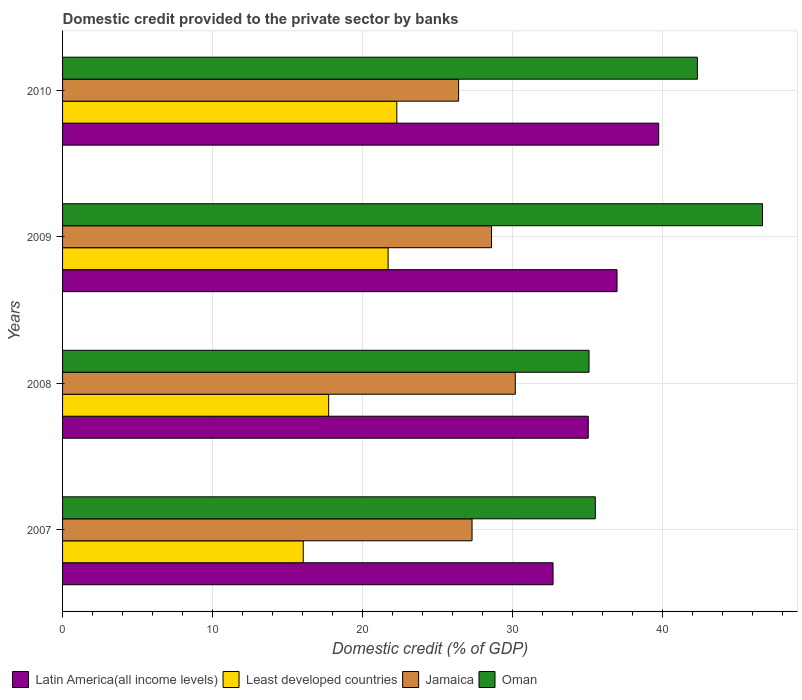How many groups of bars are there?
Your answer should be very brief. 4. In how many cases, is the number of bars for a given year not equal to the number of legend labels?
Make the answer very short. 0. What is the domestic credit provided to the private sector by banks in Latin America(all income levels) in 2010?
Your answer should be very brief. 39.76. Across all years, what is the maximum domestic credit provided to the private sector by banks in Least developed countries?
Ensure brevity in your answer.  22.29. Across all years, what is the minimum domestic credit provided to the private sector by banks in Latin America(all income levels)?
Your answer should be compact. 32.71. In which year was the domestic credit provided to the private sector by banks in Jamaica maximum?
Your answer should be compact. 2008. What is the total domestic credit provided to the private sector by banks in Latin America(all income levels) in the graph?
Your answer should be compact. 144.5. What is the difference between the domestic credit provided to the private sector by banks in Latin America(all income levels) in 2008 and that in 2010?
Your response must be concise. -4.7. What is the difference between the domestic credit provided to the private sector by banks in Jamaica in 2010 and the domestic credit provided to the private sector by banks in Least developed countries in 2009?
Give a very brief answer. 4.7. What is the average domestic credit provided to the private sector by banks in Latin America(all income levels) per year?
Offer a terse response. 36.12. In the year 2008, what is the difference between the domestic credit provided to the private sector by banks in Jamaica and domestic credit provided to the private sector by banks in Latin America(all income levels)?
Keep it short and to the point. -4.87. What is the ratio of the domestic credit provided to the private sector by banks in Least developed countries in 2009 to that in 2010?
Your answer should be compact. 0.97. What is the difference between the highest and the second highest domestic credit provided to the private sector by banks in Jamaica?
Your answer should be compact. 1.58. What is the difference between the highest and the lowest domestic credit provided to the private sector by banks in Oman?
Your answer should be very brief. 11.57. In how many years, is the domestic credit provided to the private sector by banks in Least developed countries greater than the average domestic credit provided to the private sector by banks in Least developed countries taken over all years?
Offer a very short reply. 2. What does the 2nd bar from the top in 2010 represents?
Keep it short and to the point. Jamaica. What does the 4th bar from the bottom in 2009 represents?
Offer a very short reply. Oman. Is it the case that in every year, the sum of the domestic credit provided to the private sector by banks in Oman and domestic credit provided to the private sector by banks in Latin America(all income levels) is greater than the domestic credit provided to the private sector by banks in Jamaica?
Give a very brief answer. Yes. Are all the bars in the graph horizontal?
Provide a succinct answer. Yes. Are the values on the major ticks of X-axis written in scientific E-notation?
Provide a succinct answer. No. Does the graph contain any zero values?
Offer a very short reply. No. Does the graph contain grids?
Your answer should be very brief. Yes. Where does the legend appear in the graph?
Your answer should be very brief. Bottom left. What is the title of the graph?
Provide a short and direct response. Domestic credit provided to the private sector by banks. What is the label or title of the X-axis?
Your answer should be compact. Domestic credit (% of GDP). What is the Domestic credit (% of GDP) in Latin America(all income levels) in 2007?
Provide a short and direct response. 32.71. What is the Domestic credit (% of GDP) of Least developed countries in 2007?
Give a very brief answer. 16.05. What is the Domestic credit (% of GDP) in Jamaica in 2007?
Offer a terse response. 27.31. What is the Domestic credit (% of GDP) in Oman in 2007?
Your response must be concise. 35.53. What is the Domestic credit (% of GDP) in Latin America(all income levels) in 2008?
Ensure brevity in your answer.  35.06. What is the Domestic credit (% of GDP) of Least developed countries in 2008?
Keep it short and to the point. 17.75. What is the Domestic credit (% of GDP) of Jamaica in 2008?
Give a very brief answer. 30.19. What is the Domestic credit (% of GDP) in Oman in 2008?
Provide a short and direct response. 35.11. What is the Domestic credit (% of GDP) of Latin America(all income levels) in 2009?
Provide a succinct answer. 36.98. What is the Domestic credit (% of GDP) in Least developed countries in 2009?
Keep it short and to the point. 21.71. What is the Domestic credit (% of GDP) of Jamaica in 2009?
Offer a terse response. 28.61. What is the Domestic credit (% of GDP) of Oman in 2009?
Keep it short and to the point. 46.68. What is the Domestic credit (% of GDP) of Latin America(all income levels) in 2010?
Make the answer very short. 39.76. What is the Domestic credit (% of GDP) of Least developed countries in 2010?
Offer a terse response. 22.29. What is the Domestic credit (% of GDP) of Jamaica in 2010?
Ensure brevity in your answer.  26.41. What is the Domestic credit (% of GDP) of Oman in 2010?
Offer a very short reply. 42.33. Across all years, what is the maximum Domestic credit (% of GDP) of Latin America(all income levels)?
Your response must be concise. 39.76. Across all years, what is the maximum Domestic credit (% of GDP) in Least developed countries?
Offer a very short reply. 22.29. Across all years, what is the maximum Domestic credit (% of GDP) in Jamaica?
Ensure brevity in your answer.  30.19. Across all years, what is the maximum Domestic credit (% of GDP) in Oman?
Offer a very short reply. 46.68. Across all years, what is the minimum Domestic credit (% of GDP) of Latin America(all income levels)?
Ensure brevity in your answer.  32.71. Across all years, what is the minimum Domestic credit (% of GDP) in Least developed countries?
Make the answer very short. 16.05. Across all years, what is the minimum Domestic credit (% of GDP) in Jamaica?
Offer a terse response. 26.41. Across all years, what is the minimum Domestic credit (% of GDP) of Oman?
Offer a terse response. 35.11. What is the total Domestic credit (% of GDP) of Latin America(all income levels) in the graph?
Make the answer very short. 144.5. What is the total Domestic credit (% of GDP) in Least developed countries in the graph?
Give a very brief answer. 77.8. What is the total Domestic credit (% of GDP) of Jamaica in the graph?
Provide a succinct answer. 112.52. What is the total Domestic credit (% of GDP) of Oman in the graph?
Make the answer very short. 159.65. What is the difference between the Domestic credit (% of GDP) of Latin America(all income levels) in 2007 and that in 2008?
Your response must be concise. -2.35. What is the difference between the Domestic credit (% of GDP) in Least developed countries in 2007 and that in 2008?
Make the answer very short. -1.7. What is the difference between the Domestic credit (% of GDP) of Jamaica in 2007 and that in 2008?
Provide a short and direct response. -2.88. What is the difference between the Domestic credit (% of GDP) of Oman in 2007 and that in 2008?
Provide a short and direct response. 0.42. What is the difference between the Domestic credit (% of GDP) in Latin America(all income levels) in 2007 and that in 2009?
Make the answer very short. -4.27. What is the difference between the Domestic credit (% of GDP) of Least developed countries in 2007 and that in 2009?
Ensure brevity in your answer.  -5.66. What is the difference between the Domestic credit (% of GDP) in Jamaica in 2007 and that in 2009?
Provide a succinct answer. -1.3. What is the difference between the Domestic credit (% of GDP) of Oman in 2007 and that in 2009?
Ensure brevity in your answer.  -11.15. What is the difference between the Domestic credit (% of GDP) in Latin America(all income levels) in 2007 and that in 2010?
Provide a short and direct response. -7.05. What is the difference between the Domestic credit (% of GDP) in Least developed countries in 2007 and that in 2010?
Keep it short and to the point. -6.24. What is the difference between the Domestic credit (% of GDP) in Jamaica in 2007 and that in 2010?
Make the answer very short. 0.9. What is the difference between the Domestic credit (% of GDP) of Oman in 2007 and that in 2010?
Your answer should be very brief. -6.81. What is the difference between the Domestic credit (% of GDP) of Latin America(all income levels) in 2008 and that in 2009?
Provide a short and direct response. -1.92. What is the difference between the Domestic credit (% of GDP) of Least developed countries in 2008 and that in 2009?
Provide a succinct answer. -3.96. What is the difference between the Domestic credit (% of GDP) in Jamaica in 2008 and that in 2009?
Provide a short and direct response. 1.58. What is the difference between the Domestic credit (% of GDP) in Oman in 2008 and that in 2009?
Provide a succinct answer. -11.57. What is the difference between the Domestic credit (% of GDP) of Latin America(all income levels) in 2008 and that in 2010?
Provide a succinct answer. -4.7. What is the difference between the Domestic credit (% of GDP) in Least developed countries in 2008 and that in 2010?
Provide a short and direct response. -4.54. What is the difference between the Domestic credit (% of GDP) of Jamaica in 2008 and that in 2010?
Your response must be concise. 3.78. What is the difference between the Domestic credit (% of GDP) of Oman in 2008 and that in 2010?
Provide a succinct answer. -7.23. What is the difference between the Domestic credit (% of GDP) in Latin America(all income levels) in 2009 and that in 2010?
Provide a succinct answer. -2.78. What is the difference between the Domestic credit (% of GDP) in Least developed countries in 2009 and that in 2010?
Offer a terse response. -0.58. What is the difference between the Domestic credit (% of GDP) of Jamaica in 2009 and that in 2010?
Ensure brevity in your answer.  2.2. What is the difference between the Domestic credit (% of GDP) in Oman in 2009 and that in 2010?
Offer a terse response. 4.34. What is the difference between the Domestic credit (% of GDP) in Latin America(all income levels) in 2007 and the Domestic credit (% of GDP) in Least developed countries in 2008?
Keep it short and to the point. 14.96. What is the difference between the Domestic credit (% of GDP) of Latin America(all income levels) in 2007 and the Domestic credit (% of GDP) of Jamaica in 2008?
Keep it short and to the point. 2.52. What is the difference between the Domestic credit (% of GDP) of Least developed countries in 2007 and the Domestic credit (% of GDP) of Jamaica in 2008?
Your answer should be very brief. -14.14. What is the difference between the Domestic credit (% of GDP) in Least developed countries in 2007 and the Domestic credit (% of GDP) in Oman in 2008?
Make the answer very short. -19.06. What is the difference between the Domestic credit (% of GDP) in Jamaica in 2007 and the Domestic credit (% of GDP) in Oman in 2008?
Give a very brief answer. -7.8. What is the difference between the Domestic credit (% of GDP) in Latin America(all income levels) in 2007 and the Domestic credit (% of GDP) in Least developed countries in 2009?
Make the answer very short. 11. What is the difference between the Domestic credit (% of GDP) of Latin America(all income levels) in 2007 and the Domestic credit (% of GDP) of Jamaica in 2009?
Provide a short and direct response. 4.1. What is the difference between the Domestic credit (% of GDP) in Latin America(all income levels) in 2007 and the Domestic credit (% of GDP) in Oman in 2009?
Your answer should be compact. -13.97. What is the difference between the Domestic credit (% of GDP) in Least developed countries in 2007 and the Domestic credit (% of GDP) in Jamaica in 2009?
Your answer should be compact. -12.56. What is the difference between the Domestic credit (% of GDP) of Least developed countries in 2007 and the Domestic credit (% of GDP) of Oman in 2009?
Provide a short and direct response. -30.63. What is the difference between the Domestic credit (% of GDP) of Jamaica in 2007 and the Domestic credit (% of GDP) of Oman in 2009?
Give a very brief answer. -19.37. What is the difference between the Domestic credit (% of GDP) of Latin America(all income levels) in 2007 and the Domestic credit (% of GDP) of Least developed countries in 2010?
Keep it short and to the point. 10.42. What is the difference between the Domestic credit (% of GDP) in Latin America(all income levels) in 2007 and the Domestic credit (% of GDP) in Jamaica in 2010?
Your answer should be compact. 6.3. What is the difference between the Domestic credit (% of GDP) of Latin America(all income levels) in 2007 and the Domestic credit (% of GDP) of Oman in 2010?
Your answer should be very brief. -9.63. What is the difference between the Domestic credit (% of GDP) of Least developed countries in 2007 and the Domestic credit (% of GDP) of Jamaica in 2010?
Provide a succinct answer. -10.36. What is the difference between the Domestic credit (% of GDP) of Least developed countries in 2007 and the Domestic credit (% of GDP) of Oman in 2010?
Ensure brevity in your answer.  -26.28. What is the difference between the Domestic credit (% of GDP) in Jamaica in 2007 and the Domestic credit (% of GDP) in Oman in 2010?
Give a very brief answer. -15.03. What is the difference between the Domestic credit (% of GDP) of Latin America(all income levels) in 2008 and the Domestic credit (% of GDP) of Least developed countries in 2009?
Your answer should be very brief. 13.35. What is the difference between the Domestic credit (% of GDP) in Latin America(all income levels) in 2008 and the Domestic credit (% of GDP) in Jamaica in 2009?
Provide a succinct answer. 6.45. What is the difference between the Domestic credit (% of GDP) of Latin America(all income levels) in 2008 and the Domestic credit (% of GDP) of Oman in 2009?
Ensure brevity in your answer.  -11.62. What is the difference between the Domestic credit (% of GDP) in Least developed countries in 2008 and the Domestic credit (% of GDP) in Jamaica in 2009?
Offer a terse response. -10.86. What is the difference between the Domestic credit (% of GDP) in Least developed countries in 2008 and the Domestic credit (% of GDP) in Oman in 2009?
Provide a short and direct response. -28.93. What is the difference between the Domestic credit (% of GDP) in Jamaica in 2008 and the Domestic credit (% of GDP) in Oman in 2009?
Ensure brevity in your answer.  -16.48. What is the difference between the Domestic credit (% of GDP) of Latin America(all income levels) in 2008 and the Domestic credit (% of GDP) of Least developed countries in 2010?
Offer a very short reply. 12.77. What is the difference between the Domestic credit (% of GDP) in Latin America(all income levels) in 2008 and the Domestic credit (% of GDP) in Jamaica in 2010?
Keep it short and to the point. 8.65. What is the difference between the Domestic credit (% of GDP) in Latin America(all income levels) in 2008 and the Domestic credit (% of GDP) in Oman in 2010?
Provide a short and direct response. -7.28. What is the difference between the Domestic credit (% of GDP) in Least developed countries in 2008 and the Domestic credit (% of GDP) in Jamaica in 2010?
Offer a very short reply. -8.66. What is the difference between the Domestic credit (% of GDP) in Least developed countries in 2008 and the Domestic credit (% of GDP) in Oman in 2010?
Provide a succinct answer. -24.59. What is the difference between the Domestic credit (% of GDP) in Jamaica in 2008 and the Domestic credit (% of GDP) in Oman in 2010?
Offer a very short reply. -12.14. What is the difference between the Domestic credit (% of GDP) of Latin America(all income levels) in 2009 and the Domestic credit (% of GDP) of Least developed countries in 2010?
Your answer should be very brief. 14.69. What is the difference between the Domestic credit (% of GDP) of Latin America(all income levels) in 2009 and the Domestic credit (% of GDP) of Jamaica in 2010?
Make the answer very short. 10.57. What is the difference between the Domestic credit (% of GDP) of Latin America(all income levels) in 2009 and the Domestic credit (% of GDP) of Oman in 2010?
Provide a succinct answer. -5.36. What is the difference between the Domestic credit (% of GDP) in Least developed countries in 2009 and the Domestic credit (% of GDP) in Jamaica in 2010?
Your response must be concise. -4.7. What is the difference between the Domestic credit (% of GDP) in Least developed countries in 2009 and the Domestic credit (% of GDP) in Oman in 2010?
Give a very brief answer. -20.62. What is the difference between the Domestic credit (% of GDP) in Jamaica in 2009 and the Domestic credit (% of GDP) in Oman in 2010?
Provide a succinct answer. -13.73. What is the average Domestic credit (% of GDP) of Latin America(all income levels) per year?
Offer a very short reply. 36.12. What is the average Domestic credit (% of GDP) of Least developed countries per year?
Give a very brief answer. 19.45. What is the average Domestic credit (% of GDP) in Jamaica per year?
Your response must be concise. 28.13. What is the average Domestic credit (% of GDP) of Oman per year?
Your answer should be compact. 39.91. In the year 2007, what is the difference between the Domestic credit (% of GDP) of Latin America(all income levels) and Domestic credit (% of GDP) of Least developed countries?
Offer a very short reply. 16.66. In the year 2007, what is the difference between the Domestic credit (% of GDP) of Latin America(all income levels) and Domestic credit (% of GDP) of Jamaica?
Your response must be concise. 5.4. In the year 2007, what is the difference between the Domestic credit (% of GDP) of Latin America(all income levels) and Domestic credit (% of GDP) of Oman?
Make the answer very short. -2.82. In the year 2007, what is the difference between the Domestic credit (% of GDP) in Least developed countries and Domestic credit (% of GDP) in Jamaica?
Give a very brief answer. -11.26. In the year 2007, what is the difference between the Domestic credit (% of GDP) in Least developed countries and Domestic credit (% of GDP) in Oman?
Offer a terse response. -19.48. In the year 2007, what is the difference between the Domestic credit (% of GDP) in Jamaica and Domestic credit (% of GDP) in Oman?
Your answer should be compact. -8.22. In the year 2008, what is the difference between the Domestic credit (% of GDP) of Latin America(all income levels) and Domestic credit (% of GDP) of Least developed countries?
Make the answer very short. 17.31. In the year 2008, what is the difference between the Domestic credit (% of GDP) in Latin America(all income levels) and Domestic credit (% of GDP) in Jamaica?
Keep it short and to the point. 4.87. In the year 2008, what is the difference between the Domestic credit (% of GDP) of Latin America(all income levels) and Domestic credit (% of GDP) of Oman?
Give a very brief answer. -0.05. In the year 2008, what is the difference between the Domestic credit (% of GDP) of Least developed countries and Domestic credit (% of GDP) of Jamaica?
Keep it short and to the point. -12.45. In the year 2008, what is the difference between the Domestic credit (% of GDP) of Least developed countries and Domestic credit (% of GDP) of Oman?
Make the answer very short. -17.36. In the year 2008, what is the difference between the Domestic credit (% of GDP) of Jamaica and Domestic credit (% of GDP) of Oman?
Give a very brief answer. -4.92. In the year 2009, what is the difference between the Domestic credit (% of GDP) in Latin America(all income levels) and Domestic credit (% of GDP) in Least developed countries?
Give a very brief answer. 15.27. In the year 2009, what is the difference between the Domestic credit (% of GDP) in Latin America(all income levels) and Domestic credit (% of GDP) in Jamaica?
Offer a terse response. 8.37. In the year 2009, what is the difference between the Domestic credit (% of GDP) of Latin America(all income levels) and Domestic credit (% of GDP) of Oman?
Your answer should be very brief. -9.7. In the year 2009, what is the difference between the Domestic credit (% of GDP) of Least developed countries and Domestic credit (% of GDP) of Jamaica?
Your answer should be very brief. -6.9. In the year 2009, what is the difference between the Domestic credit (% of GDP) in Least developed countries and Domestic credit (% of GDP) in Oman?
Give a very brief answer. -24.97. In the year 2009, what is the difference between the Domestic credit (% of GDP) in Jamaica and Domestic credit (% of GDP) in Oman?
Offer a very short reply. -18.07. In the year 2010, what is the difference between the Domestic credit (% of GDP) in Latin America(all income levels) and Domestic credit (% of GDP) in Least developed countries?
Provide a succinct answer. 17.47. In the year 2010, what is the difference between the Domestic credit (% of GDP) of Latin America(all income levels) and Domestic credit (% of GDP) of Jamaica?
Your answer should be very brief. 13.35. In the year 2010, what is the difference between the Domestic credit (% of GDP) in Latin America(all income levels) and Domestic credit (% of GDP) in Oman?
Ensure brevity in your answer.  -2.58. In the year 2010, what is the difference between the Domestic credit (% of GDP) in Least developed countries and Domestic credit (% of GDP) in Jamaica?
Your answer should be very brief. -4.12. In the year 2010, what is the difference between the Domestic credit (% of GDP) of Least developed countries and Domestic credit (% of GDP) of Oman?
Offer a very short reply. -20.04. In the year 2010, what is the difference between the Domestic credit (% of GDP) of Jamaica and Domestic credit (% of GDP) of Oman?
Offer a terse response. -15.92. What is the ratio of the Domestic credit (% of GDP) of Latin America(all income levels) in 2007 to that in 2008?
Ensure brevity in your answer.  0.93. What is the ratio of the Domestic credit (% of GDP) in Least developed countries in 2007 to that in 2008?
Give a very brief answer. 0.9. What is the ratio of the Domestic credit (% of GDP) of Jamaica in 2007 to that in 2008?
Offer a very short reply. 0.9. What is the ratio of the Domestic credit (% of GDP) in Oman in 2007 to that in 2008?
Provide a succinct answer. 1.01. What is the ratio of the Domestic credit (% of GDP) in Latin America(all income levels) in 2007 to that in 2009?
Provide a succinct answer. 0.88. What is the ratio of the Domestic credit (% of GDP) of Least developed countries in 2007 to that in 2009?
Ensure brevity in your answer.  0.74. What is the ratio of the Domestic credit (% of GDP) in Jamaica in 2007 to that in 2009?
Give a very brief answer. 0.95. What is the ratio of the Domestic credit (% of GDP) of Oman in 2007 to that in 2009?
Your response must be concise. 0.76. What is the ratio of the Domestic credit (% of GDP) in Latin America(all income levels) in 2007 to that in 2010?
Keep it short and to the point. 0.82. What is the ratio of the Domestic credit (% of GDP) in Least developed countries in 2007 to that in 2010?
Your answer should be very brief. 0.72. What is the ratio of the Domestic credit (% of GDP) of Jamaica in 2007 to that in 2010?
Keep it short and to the point. 1.03. What is the ratio of the Domestic credit (% of GDP) in Oman in 2007 to that in 2010?
Give a very brief answer. 0.84. What is the ratio of the Domestic credit (% of GDP) in Latin America(all income levels) in 2008 to that in 2009?
Give a very brief answer. 0.95. What is the ratio of the Domestic credit (% of GDP) in Least developed countries in 2008 to that in 2009?
Ensure brevity in your answer.  0.82. What is the ratio of the Domestic credit (% of GDP) in Jamaica in 2008 to that in 2009?
Your response must be concise. 1.06. What is the ratio of the Domestic credit (% of GDP) in Oman in 2008 to that in 2009?
Offer a very short reply. 0.75. What is the ratio of the Domestic credit (% of GDP) in Latin America(all income levels) in 2008 to that in 2010?
Your answer should be very brief. 0.88. What is the ratio of the Domestic credit (% of GDP) in Least developed countries in 2008 to that in 2010?
Your answer should be compact. 0.8. What is the ratio of the Domestic credit (% of GDP) in Jamaica in 2008 to that in 2010?
Make the answer very short. 1.14. What is the ratio of the Domestic credit (% of GDP) in Oman in 2008 to that in 2010?
Your answer should be very brief. 0.83. What is the ratio of the Domestic credit (% of GDP) in Latin America(all income levels) in 2009 to that in 2010?
Your response must be concise. 0.93. What is the ratio of the Domestic credit (% of GDP) of Least developed countries in 2009 to that in 2010?
Ensure brevity in your answer.  0.97. What is the ratio of the Domestic credit (% of GDP) in Jamaica in 2009 to that in 2010?
Your answer should be compact. 1.08. What is the ratio of the Domestic credit (% of GDP) in Oman in 2009 to that in 2010?
Ensure brevity in your answer.  1.1. What is the difference between the highest and the second highest Domestic credit (% of GDP) of Latin America(all income levels)?
Provide a succinct answer. 2.78. What is the difference between the highest and the second highest Domestic credit (% of GDP) of Least developed countries?
Give a very brief answer. 0.58. What is the difference between the highest and the second highest Domestic credit (% of GDP) of Jamaica?
Your answer should be compact. 1.58. What is the difference between the highest and the second highest Domestic credit (% of GDP) in Oman?
Your answer should be compact. 4.34. What is the difference between the highest and the lowest Domestic credit (% of GDP) of Latin America(all income levels)?
Offer a very short reply. 7.05. What is the difference between the highest and the lowest Domestic credit (% of GDP) of Least developed countries?
Give a very brief answer. 6.24. What is the difference between the highest and the lowest Domestic credit (% of GDP) of Jamaica?
Offer a terse response. 3.78. What is the difference between the highest and the lowest Domestic credit (% of GDP) of Oman?
Your answer should be very brief. 11.57. 